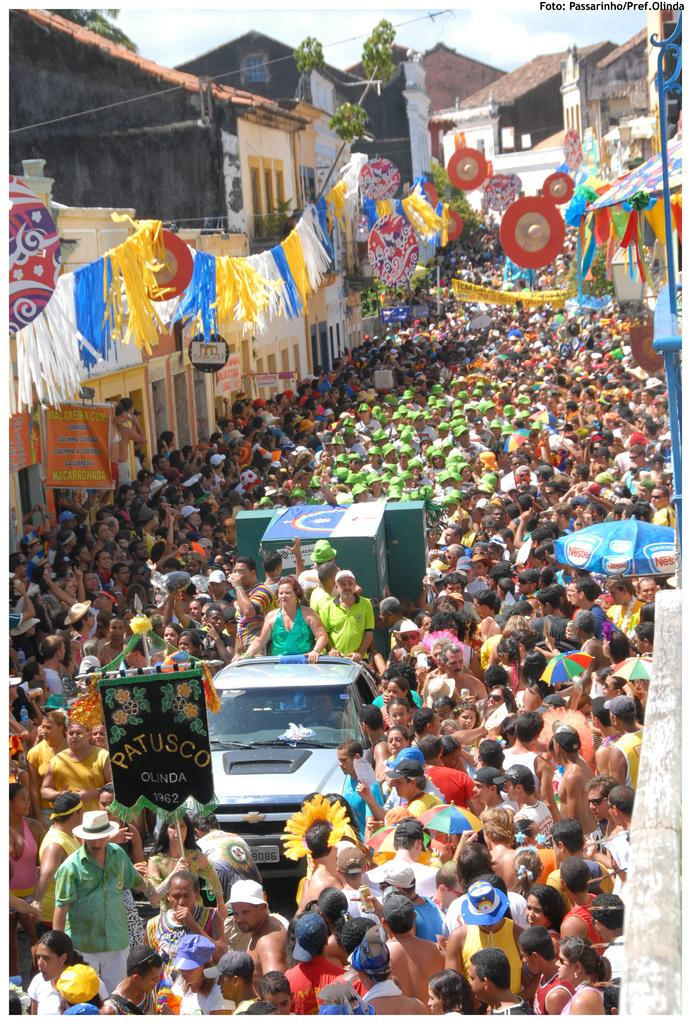What is the setting of the image? The image shows an outside view. What can be seen between the buildings in the image? There is a crowd in between buildings. Can you describe the people in the image? There are persons standing on a vehicle in the middle of the image. What brand of toothpaste is being advertised on the buildings in the image? There is no toothpaste or advertisement visible in the image. Where can the lunchroom be found in the image? There is no lunchroom present in the image. 